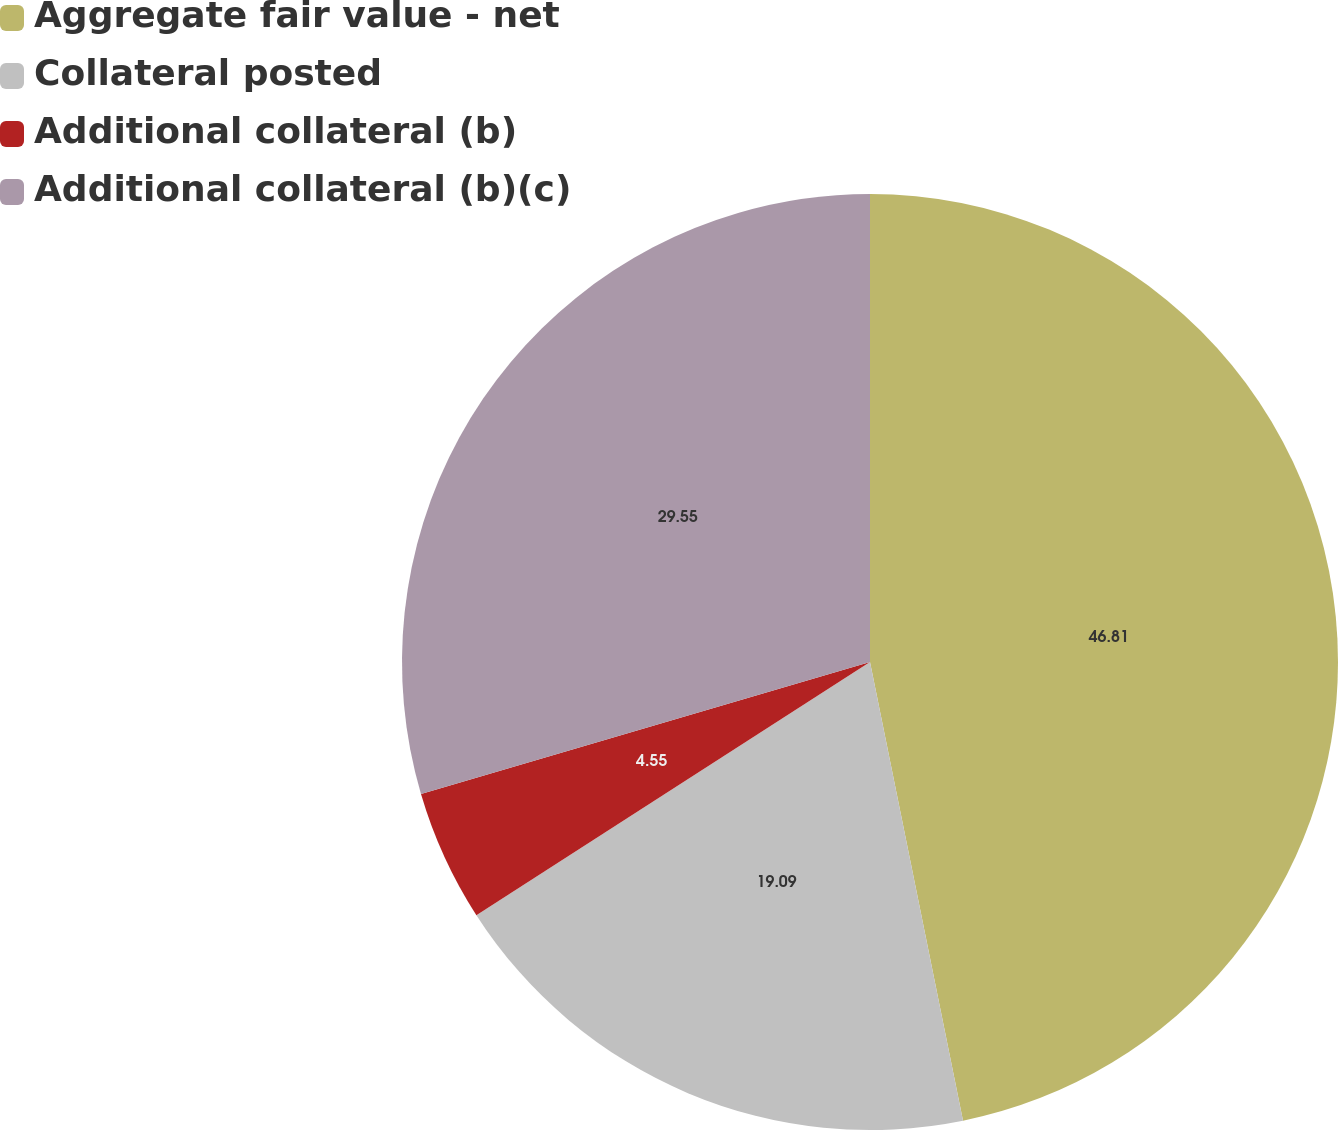<chart> <loc_0><loc_0><loc_500><loc_500><pie_chart><fcel>Aggregate fair value - net<fcel>Collateral posted<fcel>Additional collateral (b)<fcel>Additional collateral (b)(c)<nl><fcel>46.82%<fcel>19.09%<fcel>4.55%<fcel>29.55%<nl></chart> 